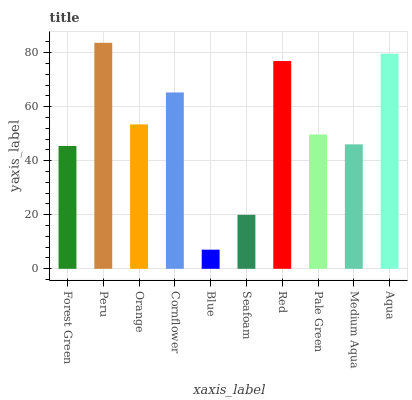Is Blue the minimum?
Answer yes or no. Yes. Is Peru the maximum?
Answer yes or no. Yes. Is Orange the minimum?
Answer yes or no. No. Is Orange the maximum?
Answer yes or no. No. Is Peru greater than Orange?
Answer yes or no. Yes. Is Orange less than Peru?
Answer yes or no. Yes. Is Orange greater than Peru?
Answer yes or no. No. Is Peru less than Orange?
Answer yes or no. No. Is Orange the high median?
Answer yes or no. Yes. Is Pale Green the low median?
Answer yes or no. Yes. Is Medium Aqua the high median?
Answer yes or no. No. Is Orange the low median?
Answer yes or no. No. 